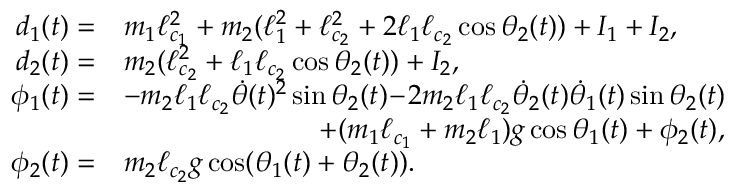Convert formula to latex. <formula><loc_0><loc_0><loc_500><loc_500>\begin{array} { r l } { d _ { 1 } ( t ) = } & { m _ { 1 } \ell _ { c _ { 1 } } ^ { 2 } + m _ { 2 } ( \ell _ { 1 } ^ { 2 } + \ell _ { c _ { 2 } } ^ { 2 } + 2 \ell _ { 1 } \ell _ { c _ { 2 } } \cos \theta _ { 2 } ( t ) ) + I _ { 1 } + I _ { 2 } , } \\ { d _ { 2 } ( t ) = } & { m _ { 2 } ( \ell _ { c _ { 2 } } ^ { 2 } + \ell _ { 1 } \ell _ { c _ { 2 } } \cos \theta _ { 2 } ( t ) ) + I _ { 2 } , } \\ { \phi _ { 1 } ( t ) = } & { - m _ { 2 } \ell _ { 1 } \ell _ { c _ { 2 } } \dot { \theta } ( t ) ^ { 2 } \sin \theta _ { 2 } ( t ) \, - \, 2 m _ { 2 } \ell _ { 1 } \ell _ { c _ { 2 } } \dot { \theta } _ { 2 } ( t ) \dot { \theta } _ { 1 } ( t ) \sin \theta _ { 2 } ( t ) } \\ & { \quad + ( m _ { 1 } \ell _ { c _ { 1 } } + m _ { 2 } \ell _ { 1 } ) g \cos \theta _ { 1 } ( t ) + \phi _ { 2 } ( t ) , } \\ { \phi _ { 2 } ( t ) = } & { m _ { 2 } \ell _ { c _ { 2 } } g \cos ( \theta _ { 1 } ( t ) + \theta _ { 2 } ( t ) ) . } \end{array}</formula> 